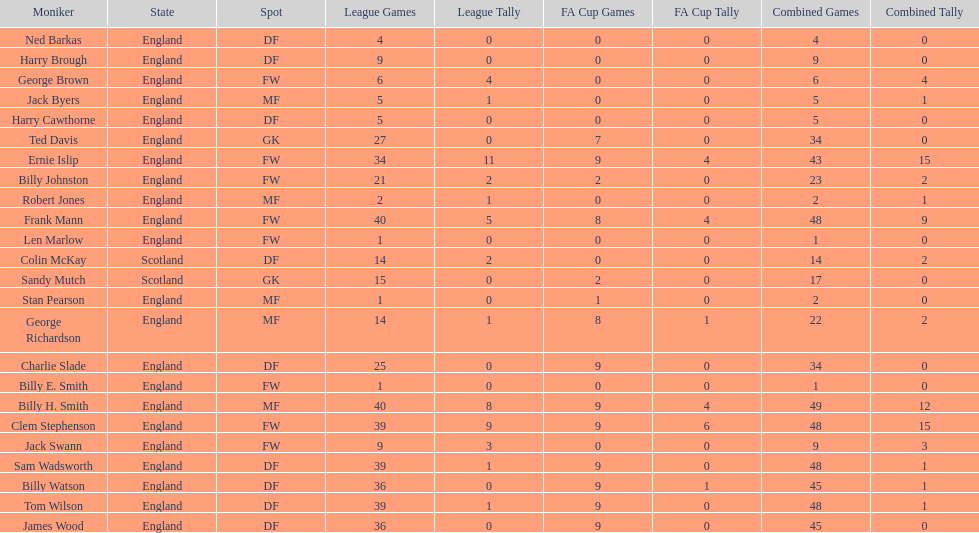The least number of total appearances 1. 